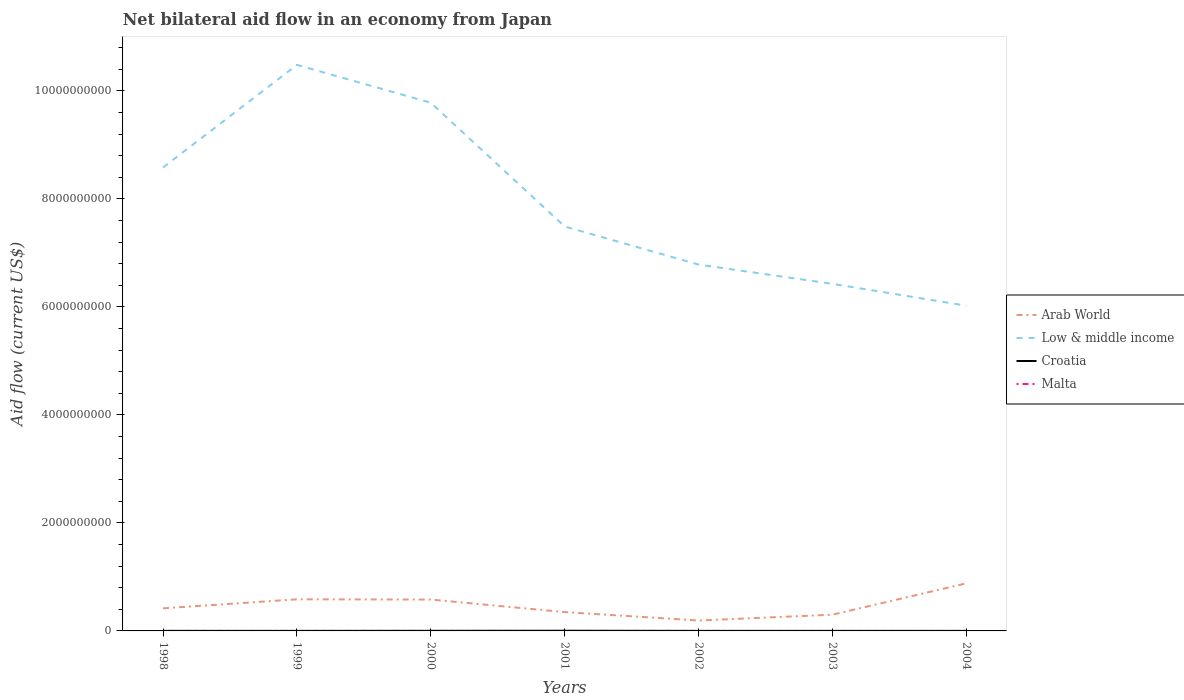Is the number of lines equal to the number of legend labels?
Your response must be concise. Yes. What is the total net bilateral aid flow in Malta in the graph?
Your answer should be very brief. 2.00e+05. What is the difference between the highest and the second highest net bilateral aid flow in Malta?
Offer a terse response. 3.60e+05. What is the difference between the highest and the lowest net bilateral aid flow in Arab World?
Your answer should be compact. 3. Is the net bilateral aid flow in Croatia strictly greater than the net bilateral aid flow in Malta over the years?
Provide a succinct answer. No. How many lines are there?
Keep it short and to the point. 4. How many years are there in the graph?
Your answer should be compact. 7. What is the difference between two consecutive major ticks on the Y-axis?
Offer a terse response. 2.00e+09. Does the graph contain any zero values?
Your answer should be very brief. No. What is the title of the graph?
Give a very brief answer. Net bilateral aid flow in an economy from Japan. Does "Turkmenistan" appear as one of the legend labels in the graph?
Your answer should be very brief. No. What is the label or title of the X-axis?
Offer a very short reply. Years. What is the label or title of the Y-axis?
Your response must be concise. Aid flow (current US$). What is the Aid flow (current US$) in Arab World in 1998?
Offer a very short reply. 4.18e+08. What is the Aid flow (current US$) in Low & middle income in 1998?
Offer a terse response. 8.58e+09. What is the Aid flow (current US$) of Croatia in 1998?
Your answer should be compact. 8.20e+05. What is the Aid flow (current US$) of Arab World in 1999?
Ensure brevity in your answer.  5.85e+08. What is the Aid flow (current US$) in Low & middle income in 1999?
Your response must be concise. 1.05e+1. What is the Aid flow (current US$) of Malta in 1999?
Provide a short and direct response. 4.20e+05. What is the Aid flow (current US$) in Arab World in 2000?
Offer a very short reply. 5.81e+08. What is the Aid flow (current US$) in Low & middle income in 2000?
Provide a succinct answer. 9.78e+09. What is the Aid flow (current US$) of Croatia in 2000?
Offer a terse response. 1.73e+06. What is the Aid flow (current US$) in Malta in 2000?
Your answer should be compact. 4.20e+05. What is the Aid flow (current US$) in Arab World in 2001?
Ensure brevity in your answer.  3.49e+08. What is the Aid flow (current US$) of Low & middle income in 2001?
Give a very brief answer. 7.49e+09. What is the Aid flow (current US$) in Croatia in 2001?
Offer a terse response. 3.24e+06. What is the Aid flow (current US$) in Arab World in 2002?
Offer a terse response. 1.93e+08. What is the Aid flow (current US$) of Low & middle income in 2002?
Keep it short and to the point. 6.78e+09. What is the Aid flow (current US$) in Croatia in 2002?
Make the answer very short. 5.10e+05. What is the Aid flow (current US$) in Arab World in 2003?
Your response must be concise. 3.01e+08. What is the Aid flow (current US$) in Low & middle income in 2003?
Ensure brevity in your answer.  6.43e+09. What is the Aid flow (current US$) of Malta in 2003?
Ensure brevity in your answer.  7.00e+04. What is the Aid flow (current US$) of Arab World in 2004?
Your answer should be very brief. 8.81e+08. What is the Aid flow (current US$) of Low & middle income in 2004?
Keep it short and to the point. 6.02e+09. What is the Aid flow (current US$) of Croatia in 2004?
Make the answer very short. 6.90e+05. Across all years, what is the maximum Aid flow (current US$) of Arab World?
Give a very brief answer. 8.81e+08. Across all years, what is the maximum Aid flow (current US$) in Low & middle income?
Provide a succinct answer. 1.05e+1. Across all years, what is the maximum Aid flow (current US$) of Croatia?
Your answer should be compact. 3.24e+06. Across all years, what is the maximum Aid flow (current US$) in Malta?
Give a very brief answer. 4.20e+05. Across all years, what is the minimum Aid flow (current US$) in Arab World?
Make the answer very short. 1.93e+08. Across all years, what is the minimum Aid flow (current US$) in Low & middle income?
Ensure brevity in your answer.  6.02e+09. Across all years, what is the minimum Aid flow (current US$) in Croatia?
Make the answer very short. 4.90e+05. Across all years, what is the minimum Aid flow (current US$) in Malta?
Give a very brief answer. 6.00e+04. What is the total Aid flow (current US$) of Arab World in the graph?
Your response must be concise. 3.31e+09. What is the total Aid flow (current US$) in Low & middle income in the graph?
Ensure brevity in your answer.  5.56e+1. What is the total Aid flow (current US$) of Croatia in the graph?
Offer a terse response. 8.48e+06. What is the total Aid flow (current US$) of Malta in the graph?
Ensure brevity in your answer.  1.65e+06. What is the difference between the Aid flow (current US$) of Arab World in 1998 and that in 1999?
Ensure brevity in your answer.  -1.67e+08. What is the difference between the Aid flow (current US$) of Low & middle income in 1998 and that in 1999?
Offer a very short reply. -1.90e+09. What is the difference between the Aid flow (current US$) of Croatia in 1998 and that in 1999?
Provide a succinct answer. 3.30e+05. What is the difference between the Aid flow (current US$) in Arab World in 1998 and that in 2000?
Ensure brevity in your answer.  -1.63e+08. What is the difference between the Aid flow (current US$) in Low & middle income in 1998 and that in 2000?
Give a very brief answer. -1.20e+09. What is the difference between the Aid flow (current US$) of Croatia in 1998 and that in 2000?
Ensure brevity in your answer.  -9.10e+05. What is the difference between the Aid flow (current US$) of Malta in 1998 and that in 2000?
Your answer should be compact. -1.40e+05. What is the difference between the Aid flow (current US$) in Arab World in 1998 and that in 2001?
Provide a short and direct response. 6.95e+07. What is the difference between the Aid flow (current US$) of Low & middle income in 1998 and that in 2001?
Your response must be concise. 1.09e+09. What is the difference between the Aid flow (current US$) of Croatia in 1998 and that in 2001?
Provide a short and direct response. -2.42e+06. What is the difference between the Aid flow (current US$) of Arab World in 1998 and that in 2002?
Your answer should be compact. 2.26e+08. What is the difference between the Aid flow (current US$) in Low & middle income in 1998 and that in 2002?
Your answer should be very brief. 1.80e+09. What is the difference between the Aid flow (current US$) in Croatia in 1998 and that in 2002?
Give a very brief answer. 3.10e+05. What is the difference between the Aid flow (current US$) of Arab World in 1998 and that in 2003?
Offer a very short reply. 1.18e+08. What is the difference between the Aid flow (current US$) of Low & middle income in 1998 and that in 2003?
Offer a very short reply. 2.15e+09. What is the difference between the Aid flow (current US$) in Croatia in 1998 and that in 2003?
Ensure brevity in your answer.  -1.80e+05. What is the difference between the Aid flow (current US$) in Malta in 1998 and that in 2003?
Offer a terse response. 2.10e+05. What is the difference between the Aid flow (current US$) in Arab World in 1998 and that in 2004?
Offer a terse response. -4.63e+08. What is the difference between the Aid flow (current US$) of Low & middle income in 1998 and that in 2004?
Give a very brief answer. 2.56e+09. What is the difference between the Aid flow (current US$) of Croatia in 1998 and that in 2004?
Provide a short and direct response. 1.30e+05. What is the difference between the Aid flow (current US$) in Malta in 1998 and that in 2004?
Offer a terse response. 2.20e+05. What is the difference between the Aid flow (current US$) in Arab World in 1999 and that in 2000?
Ensure brevity in your answer.  4.22e+06. What is the difference between the Aid flow (current US$) of Low & middle income in 1999 and that in 2000?
Ensure brevity in your answer.  7.01e+08. What is the difference between the Aid flow (current US$) of Croatia in 1999 and that in 2000?
Your answer should be compact. -1.24e+06. What is the difference between the Aid flow (current US$) in Arab World in 1999 and that in 2001?
Give a very brief answer. 2.36e+08. What is the difference between the Aid flow (current US$) in Low & middle income in 1999 and that in 2001?
Keep it short and to the point. 2.99e+09. What is the difference between the Aid flow (current US$) of Croatia in 1999 and that in 2001?
Ensure brevity in your answer.  -2.75e+06. What is the difference between the Aid flow (current US$) of Arab World in 1999 and that in 2002?
Give a very brief answer. 3.93e+08. What is the difference between the Aid flow (current US$) in Low & middle income in 1999 and that in 2002?
Give a very brief answer. 3.70e+09. What is the difference between the Aid flow (current US$) in Croatia in 1999 and that in 2002?
Provide a succinct answer. -2.00e+04. What is the difference between the Aid flow (current US$) in Arab World in 1999 and that in 2003?
Ensure brevity in your answer.  2.84e+08. What is the difference between the Aid flow (current US$) of Low & middle income in 1999 and that in 2003?
Your answer should be compact. 4.05e+09. What is the difference between the Aid flow (current US$) of Croatia in 1999 and that in 2003?
Give a very brief answer. -5.10e+05. What is the difference between the Aid flow (current US$) in Arab World in 1999 and that in 2004?
Give a very brief answer. -2.96e+08. What is the difference between the Aid flow (current US$) in Low & middle income in 1999 and that in 2004?
Offer a terse response. 4.46e+09. What is the difference between the Aid flow (current US$) in Arab World in 2000 and that in 2001?
Offer a very short reply. 2.32e+08. What is the difference between the Aid flow (current US$) of Low & middle income in 2000 and that in 2001?
Make the answer very short. 2.29e+09. What is the difference between the Aid flow (current US$) of Croatia in 2000 and that in 2001?
Your response must be concise. -1.51e+06. What is the difference between the Aid flow (current US$) of Arab World in 2000 and that in 2002?
Offer a terse response. 3.88e+08. What is the difference between the Aid flow (current US$) of Low & middle income in 2000 and that in 2002?
Offer a very short reply. 3.00e+09. What is the difference between the Aid flow (current US$) in Croatia in 2000 and that in 2002?
Ensure brevity in your answer.  1.22e+06. What is the difference between the Aid flow (current US$) of Malta in 2000 and that in 2002?
Provide a succinct answer. 2.40e+05. What is the difference between the Aid flow (current US$) of Arab World in 2000 and that in 2003?
Offer a very short reply. 2.80e+08. What is the difference between the Aid flow (current US$) of Low & middle income in 2000 and that in 2003?
Your answer should be compact. 3.35e+09. What is the difference between the Aid flow (current US$) of Croatia in 2000 and that in 2003?
Ensure brevity in your answer.  7.30e+05. What is the difference between the Aid flow (current US$) of Malta in 2000 and that in 2003?
Give a very brief answer. 3.50e+05. What is the difference between the Aid flow (current US$) of Arab World in 2000 and that in 2004?
Give a very brief answer. -3.00e+08. What is the difference between the Aid flow (current US$) of Low & middle income in 2000 and that in 2004?
Provide a short and direct response. 3.76e+09. What is the difference between the Aid flow (current US$) of Croatia in 2000 and that in 2004?
Your answer should be compact. 1.04e+06. What is the difference between the Aid flow (current US$) of Malta in 2000 and that in 2004?
Provide a succinct answer. 3.60e+05. What is the difference between the Aid flow (current US$) of Arab World in 2001 and that in 2002?
Your response must be concise. 1.56e+08. What is the difference between the Aid flow (current US$) of Low & middle income in 2001 and that in 2002?
Your answer should be compact. 7.06e+08. What is the difference between the Aid flow (current US$) in Croatia in 2001 and that in 2002?
Make the answer very short. 2.73e+06. What is the difference between the Aid flow (current US$) in Malta in 2001 and that in 2002?
Ensure brevity in your answer.  4.00e+04. What is the difference between the Aid flow (current US$) of Arab World in 2001 and that in 2003?
Keep it short and to the point. 4.80e+07. What is the difference between the Aid flow (current US$) in Low & middle income in 2001 and that in 2003?
Offer a terse response. 1.06e+09. What is the difference between the Aid flow (current US$) in Croatia in 2001 and that in 2003?
Offer a terse response. 2.24e+06. What is the difference between the Aid flow (current US$) of Arab World in 2001 and that in 2004?
Offer a terse response. -5.33e+08. What is the difference between the Aid flow (current US$) in Low & middle income in 2001 and that in 2004?
Your response must be concise. 1.47e+09. What is the difference between the Aid flow (current US$) in Croatia in 2001 and that in 2004?
Offer a terse response. 2.55e+06. What is the difference between the Aid flow (current US$) in Arab World in 2002 and that in 2003?
Provide a short and direct response. -1.08e+08. What is the difference between the Aid flow (current US$) in Low & middle income in 2002 and that in 2003?
Your answer should be compact. 3.57e+08. What is the difference between the Aid flow (current US$) in Croatia in 2002 and that in 2003?
Your answer should be very brief. -4.90e+05. What is the difference between the Aid flow (current US$) of Malta in 2002 and that in 2003?
Keep it short and to the point. 1.10e+05. What is the difference between the Aid flow (current US$) of Arab World in 2002 and that in 2004?
Ensure brevity in your answer.  -6.89e+08. What is the difference between the Aid flow (current US$) of Low & middle income in 2002 and that in 2004?
Provide a succinct answer. 7.62e+08. What is the difference between the Aid flow (current US$) in Croatia in 2002 and that in 2004?
Give a very brief answer. -1.80e+05. What is the difference between the Aid flow (current US$) of Malta in 2002 and that in 2004?
Keep it short and to the point. 1.20e+05. What is the difference between the Aid flow (current US$) in Arab World in 2003 and that in 2004?
Keep it short and to the point. -5.81e+08. What is the difference between the Aid flow (current US$) in Low & middle income in 2003 and that in 2004?
Provide a short and direct response. 4.05e+08. What is the difference between the Aid flow (current US$) in Croatia in 2003 and that in 2004?
Offer a very short reply. 3.10e+05. What is the difference between the Aid flow (current US$) in Arab World in 1998 and the Aid flow (current US$) in Low & middle income in 1999?
Ensure brevity in your answer.  -1.01e+1. What is the difference between the Aid flow (current US$) of Arab World in 1998 and the Aid flow (current US$) of Croatia in 1999?
Offer a very short reply. 4.18e+08. What is the difference between the Aid flow (current US$) of Arab World in 1998 and the Aid flow (current US$) of Malta in 1999?
Your answer should be compact. 4.18e+08. What is the difference between the Aid flow (current US$) in Low & middle income in 1998 and the Aid flow (current US$) in Croatia in 1999?
Offer a terse response. 8.58e+09. What is the difference between the Aid flow (current US$) in Low & middle income in 1998 and the Aid flow (current US$) in Malta in 1999?
Provide a short and direct response. 8.58e+09. What is the difference between the Aid flow (current US$) in Arab World in 1998 and the Aid flow (current US$) in Low & middle income in 2000?
Offer a terse response. -9.36e+09. What is the difference between the Aid flow (current US$) of Arab World in 1998 and the Aid flow (current US$) of Croatia in 2000?
Give a very brief answer. 4.17e+08. What is the difference between the Aid flow (current US$) in Arab World in 1998 and the Aid flow (current US$) in Malta in 2000?
Ensure brevity in your answer.  4.18e+08. What is the difference between the Aid flow (current US$) of Low & middle income in 1998 and the Aid flow (current US$) of Croatia in 2000?
Offer a very short reply. 8.58e+09. What is the difference between the Aid flow (current US$) in Low & middle income in 1998 and the Aid flow (current US$) in Malta in 2000?
Keep it short and to the point. 8.58e+09. What is the difference between the Aid flow (current US$) of Croatia in 1998 and the Aid flow (current US$) of Malta in 2000?
Give a very brief answer. 4.00e+05. What is the difference between the Aid flow (current US$) of Arab World in 1998 and the Aid flow (current US$) of Low & middle income in 2001?
Your response must be concise. -7.07e+09. What is the difference between the Aid flow (current US$) of Arab World in 1998 and the Aid flow (current US$) of Croatia in 2001?
Offer a terse response. 4.15e+08. What is the difference between the Aid flow (current US$) in Arab World in 1998 and the Aid flow (current US$) in Malta in 2001?
Give a very brief answer. 4.18e+08. What is the difference between the Aid flow (current US$) in Low & middle income in 1998 and the Aid flow (current US$) in Croatia in 2001?
Offer a very short reply. 8.58e+09. What is the difference between the Aid flow (current US$) of Low & middle income in 1998 and the Aid flow (current US$) of Malta in 2001?
Provide a short and direct response. 8.58e+09. What is the difference between the Aid flow (current US$) in Arab World in 1998 and the Aid flow (current US$) in Low & middle income in 2002?
Provide a short and direct response. -6.37e+09. What is the difference between the Aid flow (current US$) of Arab World in 1998 and the Aid flow (current US$) of Croatia in 2002?
Your response must be concise. 4.18e+08. What is the difference between the Aid flow (current US$) of Arab World in 1998 and the Aid flow (current US$) of Malta in 2002?
Make the answer very short. 4.18e+08. What is the difference between the Aid flow (current US$) of Low & middle income in 1998 and the Aid flow (current US$) of Croatia in 2002?
Give a very brief answer. 8.58e+09. What is the difference between the Aid flow (current US$) of Low & middle income in 1998 and the Aid flow (current US$) of Malta in 2002?
Your answer should be compact. 8.58e+09. What is the difference between the Aid flow (current US$) in Croatia in 1998 and the Aid flow (current US$) in Malta in 2002?
Your response must be concise. 6.40e+05. What is the difference between the Aid flow (current US$) of Arab World in 1998 and the Aid flow (current US$) of Low & middle income in 2003?
Your answer should be compact. -6.01e+09. What is the difference between the Aid flow (current US$) of Arab World in 1998 and the Aid flow (current US$) of Croatia in 2003?
Your answer should be very brief. 4.17e+08. What is the difference between the Aid flow (current US$) in Arab World in 1998 and the Aid flow (current US$) in Malta in 2003?
Keep it short and to the point. 4.18e+08. What is the difference between the Aid flow (current US$) in Low & middle income in 1998 and the Aid flow (current US$) in Croatia in 2003?
Your answer should be very brief. 8.58e+09. What is the difference between the Aid flow (current US$) of Low & middle income in 1998 and the Aid flow (current US$) of Malta in 2003?
Offer a terse response. 8.58e+09. What is the difference between the Aid flow (current US$) of Croatia in 1998 and the Aid flow (current US$) of Malta in 2003?
Your answer should be compact. 7.50e+05. What is the difference between the Aid flow (current US$) of Arab World in 1998 and the Aid flow (current US$) of Low & middle income in 2004?
Offer a terse response. -5.60e+09. What is the difference between the Aid flow (current US$) in Arab World in 1998 and the Aid flow (current US$) in Croatia in 2004?
Provide a succinct answer. 4.18e+08. What is the difference between the Aid flow (current US$) of Arab World in 1998 and the Aid flow (current US$) of Malta in 2004?
Provide a succinct answer. 4.18e+08. What is the difference between the Aid flow (current US$) of Low & middle income in 1998 and the Aid flow (current US$) of Croatia in 2004?
Ensure brevity in your answer.  8.58e+09. What is the difference between the Aid flow (current US$) in Low & middle income in 1998 and the Aid flow (current US$) in Malta in 2004?
Your response must be concise. 8.58e+09. What is the difference between the Aid flow (current US$) in Croatia in 1998 and the Aid flow (current US$) in Malta in 2004?
Give a very brief answer. 7.60e+05. What is the difference between the Aid flow (current US$) in Arab World in 1999 and the Aid flow (current US$) in Low & middle income in 2000?
Offer a terse response. -9.20e+09. What is the difference between the Aid flow (current US$) of Arab World in 1999 and the Aid flow (current US$) of Croatia in 2000?
Offer a very short reply. 5.83e+08. What is the difference between the Aid flow (current US$) in Arab World in 1999 and the Aid flow (current US$) in Malta in 2000?
Make the answer very short. 5.85e+08. What is the difference between the Aid flow (current US$) in Low & middle income in 1999 and the Aid flow (current US$) in Croatia in 2000?
Offer a very short reply. 1.05e+1. What is the difference between the Aid flow (current US$) of Low & middle income in 1999 and the Aid flow (current US$) of Malta in 2000?
Your response must be concise. 1.05e+1. What is the difference between the Aid flow (current US$) in Croatia in 1999 and the Aid flow (current US$) in Malta in 2000?
Offer a very short reply. 7.00e+04. What is the difference between the Aid flow (current US$) of Arab World in 1999 and the Aid flow (current US$) of Low & middle income in 2001?
Your response must be concise. -6.90e+09. What is the difference between the Aid flow (current US$) in Arab World in 1999 and the Aid flow (current US$) in Croatia in 2001?
Offer a terse response. 5.82e+08. What is the difference between the Aid flow (current US$) in Arab World in 1999 and the Aid flow (current US$) in Malta in 2001?
Offer a very short reply. 5.85e+08. What is the difference between the Aid flow (current US$) of Low & middle income in 1999 and the Aid flow (current US$) of Croatia in 2001?
Ensure brevity in your answer.  1.05e+1. What is the difference between the Aid flow (current US$) of Low & middle income in 1999 and the Aid flow (current US$) of Malta in 2001?
Keep it short and to the point. 1.05e+1. What is the difference between the Aid flow (current US$) of Croatia in 1999 and the Aid flow (current US$) of Malta in 2001?
Your response must be concise. 2.70e+05. What is the difference between the Aid flow (current US$) of Arab World in 1999 and the Aid flow (current US$) of Low & middle income in 2002?
Your answer should be very brief. -6.20e+09. What is the difference between the Aid flow (current US$) in Arab World in 1999 and the Aid flow (current US$) in Croatia in 2002?
Ensure brevity in your answer.  5.85e+08. What is the difference between the Aid flow (current US$) of Arab World in 1999 and the Aid flow (current US$) of Malta in 2002?
Provide a short and direct response. 5.85e+08. What is the difference between the Aid flow (current US$) in Low & middle income in 1999 and the Aid flow (current US$) in Croatia in 2002?
Make the answer very short. 1.05e+1. What is the difference between the Aid flow (current US$) in Low & middle income in 1999 and the Aid flow (current US$) in Malta in 2002?
Give a very brief answer. 1.05e+1. What is the difference between the Aid flow (current US$) in Croatia in 1999 and the Aid flow (current US$) in Malta in 2002?
Provide a succinct answer. 3.10e+05. What is the difference between the Aid flow (current US$) of Arab World in 1999 and the Aid flow (current US$) of Low & middle income in 2003?
Keep it short and to the point. -5.84e+09. What is the difference between the Aid flow (current US$) in Arab World in 1999 and the Aid flow (current US$) in Croatia in 2003?
Make the answer very short. 5.84e+08. What is the difference between the Aid flow (current US$) in Arab World in 1999 and the Aid flow (current US$) in Malta in 2003?
Make the answer very short. 5.85e+08. What is the difference between the Aid flow (current US$) of Low & middle income in 1999 and the Aid flow (current US$) of Croatia in 2003?
Provide a succinct answer. 1.05e+1. What is the difference between the Aid flow (current US$) of Low & middle income in 1999 and the Aid flow (current US$) of Malta in 2003?
Your response must be concise. 1.05e+1. What is the difference between the Aid flow (current US$) of Arab World in 1999 and the Aid flow (current US$) of Low & middle income in 2004?
Your answer should be very brief. -5.44e+09. What is the difference between the Aid flow (current US$) of Arab World in 1999 and the Aid flow (current US$) of Croatia in 2004?
Offer a terse response. 5.85e+08. What is the difference between the Aid flow (current US$) in Arab World in 1999 and the Aid flow (current US$) in Malta in 2004?
Give a very brief answer. 5.85e+08. What is the difference between the Aid flow (current US$) of Low & middle income in 1999 and the Aid flow (current US$) of Croatia in 2004?
Provide a succinct answer. 1.05e+1. What is the difference between the Aid flow (current US$) of Low & middle income in 1999 and the Aid flow (current US$) of Malta in 2004?
Your response must be concise. 1.05e+1. What is the difference between the Aid flow (current US$) in Arab World in 2000 and the Aid flow (current US$) in Low & middle income in 2001?
Make the answer very short. -6.91e+09. What is the difference between the Aid flow (current US$) of Arab World in 2000 and the Aid flow (current US$) of Croatia in 2001?
Offer a terse response. 5.78e+08. What is the difference between the Aid flow (current US$) of Arab World in 2000 and the Aid flow (current US$) of Malta in 2001?
Provide a short and direct response. 5.81e+08. What is the difference between the Aid flow (current US$) of Low & middle income in 2000 and the Aid flow (current US$) of Croatia in 2001?
Offer a terse response. 9.78e+09. What is the difference between the Aid flow (current US$) in Low & middle income in 2000 and the Aid flow (current US$) in Malta in 2001?
Provide a short and direct response. 9.78e+09. What is the difference between the Aid flow (current US$) of Croatia in 2000 and the Aid flow (current US$) of Malta in 2001?
Ensure brevity in your answer.  1.51e+06. What is the difference between the Aid flow (current US$) of Arab World in 2000 and the Aid flow (current US$) of Low & middle income in 2002?
Provide a short and direct response. -6.20e+09. What is the difference between the Aid flow (current US$) of Arab World in 2000 and the Aid flow (current US$) of Croatia in 2002?
Provide a succinct answer. 5.80e+08. What is the difference between the Aid flow (current US$) of Arab World in 2000 and the Aid flow (current US$) of Malta in 2002?
Make the answer very short. 5.81e+08. What is the difference between the Aid flow (current US$) of Low & middle income in 2000 and the Aid flow (current US$) of Croatia in 2002?
Your answer should be very brief. 9.78e+09. What is the difference between the Aid flow (current US$) in Low & middle income in 2000 and the Aid flow (current US$) in Malta in 2002?
Provide a short and direct response. 9.78e+09. What is the difference between the Aid flow (current US$) in Croatia in 2000 and the Aid flow (current US$) in Malta in 2002?
Provide a succinct answer. 1.55e+06. What is the difference between the Aid flow (current US$) of Arab World in 2000 and the Aid flow (current US$) of Low & middle income in 2003?
Your answer should be compact. -5.85e+09. What is the difference between the Aid flow (current US$) in Arab World in 2000 and the Aid flow (current US$) in Croatia in 2003?
Keep it short and to the point. 5.80e+08. What is the difference between the Aid flow (current US$) of Arab World in 2000 and the Aid flow (current US$) of Malta in 2003?
Your answer should be very brief. 5.81e+08. What is the difference between the Aid flow (current US$) in Low & middle income in 2000 and the Aid flow (current US$) in Croatia in 2003?
Give a very brief answer. 9.78e+09. What is the difference between the Aid flow (current US$) of Low & middle income in 2000 and the Aid flow (current US$) of Malta in 2003?
Ensure brevity in your answer.  9.78e+09. What is the difference between the Aid flow (current US$) of Croatia in 2000 and the Aid flow (current US$) of Malta in 2003?
Ensure brevity in your answer.  1.66e+06. What is the difference between the Aid flow (current US$) of Arab World in 2000 and the Aid flow (current US$) of Low & middle income in 2004?
Provide a succinct answer. -5.44e+09. What is the difference between the Aid flow (current US$) of Arab World in 2000 and the Aid flow (current US$) of Croatia in 2004?
Make the answer very short. 5.80e+08. What is the difference between the Aid flow (current US$) of Arab World in 2000 and the Aid flow (current US$) of Malta in 2004?
Ensure brevity in your answer.  5.81e+08. What is the difference between the Aid flow (current US$) in Low & middle income in 2000 and the Aid flow (current US$) in Croatia in 2004?
Your answer should be compact. 9.78e+09. What is the difference between the Aid flow (current US$) in Low & middle income in 2000 and the Aid flow (current US$) in Malta in 2004?
Give a very brief answer. 9.78e+09. What is the difference between the Aid flow (current US$) of Croatia in 2000 and the Aid flow (current US$) of Malta in 2004?
Provide a succinct answer. 1.67e+06. What is the difference between the Aid flow (current US$) of Arab World in 2001 and the Aid flow (current US$) of Low & middle income in 2002?
Keep it short and to the point. -6.44e+09. What is the difference between the Aid flow (current US$) of Arab World in 2001 and the Aid flow (current US$) of Croatia in 2002?
Offer a terse response. 3.48e+08. What is the difference between the Aid flow (current US$) of Arab World in 2001 and the Aid flow (current US$) of Malta in 2002?
Your answer should be very brief. 3.49e+08. What is the difference between the Aid flow (current US$) in Low & middle income in 2001 and the Aid flow (current US$) in Croatia in 2002?
Give a very brief answer. 7.49e+09. What is the difference between the Aid flow (current US$) in Low & middle income in 2001 and the Aid flow (current US$) in Malta in 2002?
Give a very brief answer. 7.49e+09. What is the difference between the Aid flow (current US$) of Croatia in 2001 and the Aid flow (current US$) of Malta in 2002?
Your answer should be very brief. 3.06e+06. What is the difference between the Aid flow (current US$) in Arab World in 2001 and the Aid flow (current US$) in Low & middle income in 2003?
Provide a succinct answer. -6.08e+09. What is the difference between the Aid flow (current US$) of Arab World in 2001 and the Aid flow (current US$) of Croatia in 2003?
Provide a short and direct response. 3.48e+08. What is the difference between the Aid flow (current US$) of Arab World in 2001 and the Aid flow (current US$) of Malta in 2003?
Make the answer very short. 3.49e+08. What is the difference between the Aid flow (current US$) in Low & middle income in 2001 and the Aid flow (current US$) in Croatia in 2003?
Your answer should be compact. 7.49e+09. What is the difference between the Aid flow (current US$) in Low & middle income in 2001 and the Aid flow (current US$) in Malta in 2003?
Your answer should be compact. 7.49e+09. What is the difference between the Aid flow (current US$) in Croatia in 2001 and the Aid flow (current US$) in Malta in 2003?
Your answer should be very brief. 3.17e+06. What is the difference between the Aid flow (current US$) of Arab World in 2001 and the Aid flow (current US$) of Low & middle income in 2004?
Your answer should be compact. -5.67e+09. What is the difference between the Aid flow (current US$) in Arab World in 2001 and the Aid flow (current US$) in Croatia in 2004?
Your response must be concise. 3.48e+08. What is the difference between the Aid flow (current US$) in Arab World in 2001 and the Aid flow (current US$) in Malta in 2004?
Offer a very short reply. 3.49e+08. What is the difference between the Aid flow (current US$) in Low & middle income in 2001 and the Aid flow (current US$) in Croatia in 2004?
Offer a very short reply. 7.49e+09. What is the difference between the Aid flow (current US$) in Low & middle income in 2001 and the Aid flow (current US$) in Malta in 2004?
Your answer should be compact. 7.49e+09. What is the difference between the Aid flow (current US$) of Croatia in 2001 and the Aid flow (current US$) of Malta in 2004?
Your response must be concise. 3.18e+06. What is the difference between the Aid flow (current US$) of Arab World in 2002 and the Aid flow (current US$) of Low & middle income in 2003?
Your response must be concise. -6.23e+09. What is the difference between the Aid flow (current US$) in Arab World in 2002 and the Aid flow (current US$) in Croatia in 2003?
Give a very brief answer. 1.92e+08. What is the difference between the Aid flow (current US$) in Arab World in 2002 and the Aid flow (current US$) in Malta in 2003?
Provide a short and direct response. 1.93e+08. What is the difference between the Aid flow (current US$) in Low & middle income in 2002 and the Aid flow (current US$) in Croatia in 2003?
Provide a succinct answer. 6.78e+09. What is the difference between the Aid flow (current US$) of Low & middle income in 2002 and the Aid flow (current US$) of Malta in 2003?
Provide a succinct answer. 6.78e+09. What is the difference between the Aid flow (current US$) in Croatia in 2002 and the Aid flow (current US$) in Malta in 2003?
Your response must be concise. 4.40e+05. What is the difference between the Aid flow (current US$) of Arab World in 2002 and the Aid flow (current US$) of Low & middle income in 2004?
Provide a succinct answer. -5.83e+09. What is the difference between the Aid flow (current US$) in Arab World in 2002 and the Aid flow (current US$) in Croatia in 2004?
Keep it short and to the point. 1.92e+08. What is the difference between the Aid flow (current US$) of Arab World in 2002 and the Aid flow (current US$) of Malta in 2004?
Make the answer very short. 1.93e+08. What is the difference between the Aid flow (current US$) in Low & middle income in 2002 and the Aid flow (current US$) in Croatia in 2004?
Ensure brevity in your answer.  6.78e+09. What is the difference between the Aid flow (current US$) in Low & middle income in 2002 and the Aid flow (current US$) in Malta in 2004?
Provide a short and direct response. 6.78e+09. What is the difference between the Aid flow (current US$) of Croatia in 2002 and the Aid flow (current US$) of Malta in 2004?
Provide a succinct answer. 4.50e+05. What is the difference between the Aid flow (current US$) in Arab World in 2003 and the Aid flow (current US$) in Low & middle income in 2004?
Keep it short and to the point. -5.72e+09. What is the difference between the Aid flow (current US$) of Arab World in 2003 and the Aid flow (current US$) of Croatia in 2004?
Provide a succinct answer. 3.00e+08. What is the difference between the Aid flow (current US$) in Arab World in 2003 and the Aid flow (current US$) in Malta in 2004?
Give a very brief answer. 3.01e+08. What is the difference between the Aid flow (current US$) of Low & middle income in 2003 and the Aid flow (current US$) of Croatia in 2004?
Make the answer very short. 6.43e+09. What is the difference between the Aid flow (current US$) in Low & middle income in 2003 and the Aid flow (current US$) in Malta in 2004?
Provide a succinct answer. 6.43e+09. What is the difference between the Aid flow (current US$) of Croatia in 2003 and the Aid flow (current US$) of Malta in 2004?
Give a very brief answer. 9.40e+05. What is the average Aid flow (current US$) in Arab World per year?
Provide a succinct answer. 4.73e+08. What is the average Aid flow (current US$) in Low & middle income per year?
Offer a terse response. 7.94e+09. What is the average Aid flow (current US$) of Croatia per year?
Your answer should be compact. 1.21e+06. What is the average Aid flow (current US$) in Malta per year?
Your response must be concise. 2.36e+05. In the year 1998, what is the difference between the Aid flow (current US$) of Arab World and Aid flow (current US$) of Low & middle income?
Provide a succinct answer. -8.16e+09. In the year 1998, what is the difference between the Aid flow (current US$) of Arab World and Aid flow (current US$) of Croatia?
Offer a very short reply. 4.18e+08. In the year 1998, what is the difference between the Aid flow (current US$) in Arab World and Aid flow (current US$) in Malta?
Your answer should be compact. 4.18e+08. In the year 1998, what is the difference between the Aid flow (current US$) in Low & middle income and Aid flow (current US$) in Croatia?
Your answer should be very brief. 8.58e+09. In the year 1998, what is the difference between the Aid flow (current US$) in Low & middle income and Aid flow (current US$) in Malta?
Your answer should be very brief. 8.58e+09. In the year 1998, what is the difference between the Aid flow (current US$) in Croatia and Aid flow (current US$) in Malta?
Your response must be concise. 5.40e+05. In the year 1999, what is the difference between the Aid flow (current US$) of Arab World and Aid flow (current US$) of Low & middle income?
Make the answer very short. -9.90e+09. In the year 1999, what is the difference between the Aid flow (current US$) of Arab World and Aid flow (current US$) of Croatia?
Provide a short and direct response. 5.85e+08. In the year 1999, what is the difference between the Aid flow (current US$) of Arab World and Aid flow (current US$) of Malta?
Give a very brief answer. 5.85e+08. In the year 1999, what is the difference between the Aid flow (current US$) of Low & middle income and Aid flow (current US$) of Croatia?
Give a very brief answer. 1.05e+1. In the year 1999, what is the difference between the Aid flow (current US$) in Low & middle income and Aid flow (current US$) in Malta?
Provide a succinct answer. 1.05e+1. In the year 1999, what is the difference between the Aid flow (current US$) of Croatia and Aid flow (current US$) of Malta?
Provide a succinct answer. 7.00e+04. In the year 2000, what is the difference between the Aid flow (current US$) of Arab World and Aid flow (current US$) of Low & middle income?
Give a very brief answer. -9.20e+09. In the year 2000, what is the difference between the Aid flow (current US$) in Arab World and Aid flow (current US$) in Croatia?
Your answer should be very brief. 5.79e+08. In the year 2000, what is the difference between the Aid flow (current US$) of Arab World and Aid flow (current US$) of Malta?
Provide a short and direct response. 5.81e+08. In the year 2000, what is the difference between the Aid flow (current US$) of Low & middle income and Aid flow (current US$) of Croatia?
Make the answer very short. 9.78e+09. In the year 2000, what is the difference between the Aid flow (current US$) of Low & middle income and Aid flow (current US$) of Malta?
Ensure brevity in your answer.  9.78e+09. In the year 2000, what is the difference between the Aid flow (current US$) in Croatia and Aid flow (current US$) in Malta?
Keep it short and to the point. 1.31e+06. In the year 2001, what is the difference between the Aid flow (current US$) of Arab World and Aid flow (current US$) of Low & middle income?
Your answer should be very brief. -7.14e+09. In the year 2001, what is the difference between the Aid flow (current US$) of Arab World and Aid flow (current US$) of Croatia?
Your response must be concise. 3.46e+08. In the year 2001, what is the difference between the Aid flow (current US$) in Arab World and Aid flow (current US$) in Malta?
Provide a short and direct response. 3.49e+08. In the year 2001, what is the difference between the Aid flow (current US$) in Low & middle income and Aid flow (current US$) in Croatia?
Your answer should be very brief. 7.49e+09. In the year 2001, what is the difference between the Aid flow (current US$) in Low & middle income and Aid flow (current US$) in Malta?
Your answer should be compact. 7.49e+09. In the year 2001, what is the difference between the Aid flow (current US$) in Croatia and Aid flow (current US$) in Malta?
Your answer should be compact. 3.02e+06. In the year 2002, what is the difference between the Aid flow (current US$) of Arab World and Aid flow (current US$) of Low & middle income?
Make the answer very short. -6.59e+09. In the year 2002, what is the difference between the Aid flow (current US$) of Arab World and Aid flow (current US$) of Croatia?
Offer a very short reply. 1.92e+08. In the year 2002, what is the difference between the Aid flow (current US$) in Arab World and Aid flow (current US$) in Malta?
Provide a short and direct response. 1.92e+08. In the year 2002, what is the difference between the Aid flow (current US$) of Low & middle income and Aid flow (current US$) of Croatia?
Make the answer very short. 6.78e+09. In the year 2002, what is the difference between the Aid flow (current US$) of Low & middle income and Aid flow (current US$) of Malta?
Make the answer very short. 6.78e+09. In the year 2002, what is the difference between the Aid flow (current US$) of Croatia and Aid flow (current US$) of Malta?
Your answer should be compact. 3.30e+05. In the year 2003, what is the difference between the Aid flow (current US$) in Arab World and Aid flow (current US$) in Low & middle income?
Your answer should be compact. -6.13e+09. In the year 2003, what is the difference between the Aid flow (current US$) of Arab World and Aid flow (current US$) of Croatia?
Give a very brief answer. 3.00e+08. In the year 2003, what is the difference between the Aid flow (current US$) of Arab World and Aid flow (current US$) of Malta?
Ensure brevity in your answer.  3.01e+08. In the year 2003, what is the difference between the Aid flow (current US$) in Low & middle income and Aid flow (current US$) in Croatia?
Offer a very short reply. 6.43e+09. In the year 2003, what is the difference between the Aid flow (current US$) of Low & middle income and Aid flow (current US$) of Malta?
Make the answer very short. 6.43e+09. In the year 2003, what is the difference between the Aid flow (current US$) of Croatia and Aid flow (current US$) of Malta?
Give a very brief answer. 9.30e+05. In the year 2004, what is the difference between the Aid flow (current US$) of Arab World and Aid flow (current US$) of Low & middle income?
Your answer should be compact. -5.14e+09. In the year 2004, what is the difference between the Aid flow (current US$) in Arab World and Aid flow (current US$) in Croatia?
Offer a very short reply. 8.81e+08. In the year 2004, what is the difference between the Aid flow (current US$) in Arab World and Aid flow (current US$) in Malta?
Offer a terse response. 8.81e+08. In the year 2004, what is the difference between the Aid flow (current US$) of Low & middle income and Aid flow (current US$) of Croatia?
Keep it short and to the point. 6.02e+09. In the year 2004, what is the difference between the Aid flow (current US$) of Low & middle income and Aid flow (current US$) of Malta?
Offer a very short reply. 6.02e+09. In the year 2004, what is the difference between the Aid flow (current US$) of Croatia and Aid flow (current US$) of Malta?
Keep it short and to the point. 6.30e+05. What is the ratio of the Aid flow (current US$) of Arab World in 1998 to that in 1999?
Ensure brevity in your answer.  0.71. What is the ratio of the Aid flow (current US$) of Low & middle income in 1998 to that in 1999?
Your response must be concise. 0.82. What is the ratio of the Aid flow (current US$) of Croatia in 1998 to that in 1999?
Make the answer very short. 1.67. What is the ratio of the Aid flow (current US$) of Arab World in 1998 to that in 2000?
Keep it short and to the point. 0.72. What is the ratio of the Aid flow (current US$) of Low & middle income in 1998 to that in 2000?
Your answer should be compact. 0.88. What is the ratio of the Aid flow (current US$) of Croatia in 1998 to that in 2000?
Your answer should be compact. 0.47. What is the ratio of the Aid flow (current US$) in Malta in 1998 to that in 2000?
Make the answer very short. 0.67. What is the ratio of the Aid flow (current US$) in Arab World in 1998 to that in 2001?
Offer a terse response. 1.2. What is the ratio of the Aid flow (current US$) of Low & middle income in 1998 to that in 2001?
Your answer should be compact. 1.15. What is the ratio of the Aid flow (current US$) in Croatia in 1998 to that in 2001?
Ensure brevity in your answer.  0.25. What is the ratio of the Aid flow (current US$) of Malta in 1998 to that in 2001?
Make the answer very short. 1.27. What is the ratio of the Aid flow (current US$) in Arab World in 1998 to that in 2002?
Give a very brief answer. 2.17. What is the ratio of the Aid flow (current US$) of Low & middle income in 1998 to that in 2002?
Ensure brevity in your answer.  1.26. What is the ratio of the Aid flow (current US$) in Croatia in 1998 to that in 2002?
Provide a short and direct response. 1.61. What is the ratio of the Aid flow (current US$) of Malta in 1998 to that in 2002?
Offer a very short reply. 1.56. What is the ratio of the Aid flow (current US$) in Arab World in 1998 to that in 2003?
Ensure brevity in your answer.  1.39. What is the ratio of the Aid flow (current US$) of Low & middle income in 1998 to that in 2003?
Your answer should be compact. 1.34. What is the ratio of the Aid flow (current US$) in Croatia in 1998 to that in 2003?
Your answer should be compact. 0.82. What is the ratio of the Aid flow (current US$) of Arab World in 1998 to that in 2004?
Make the answer very short. 0.47. What is the ratio of the Aid flow (current US$) of Low & middle income in 1998 to that in 2004?
Give a very brief answer. 1.43. What is the ratio of the Aid flow (current US$) in Croatia in 1998 to that in 2004?
Your answer should be compact. 1.19. What is the ratio of the Aid flow (current US$) in Malta in 1998 to that in 2004?
Keep it short and to the point. 4.67. What is the ratio of the Aid flow (current US$) in Arab World in 1999 to that in 2000?
Give a very brief answer. 1.01. What is the ratio of the Aid flow (current US$) in Low & middle income in 1999 to that in 2000?
Your answer should be compact. 1.07. What is the ratio of the Aid flow (current US$) of Croatia in 1999 to that in 2000?
Your answer should be compact. 0.28. What is the ratio of the Aid flow (current US$) of Arab World in 1999 to that in 2001?
Provide a succinct answer. 1.68. What is the ratio of the Aid flow (current US$) of Low & middle income in 1999 to that in 2001?
Your answer should be compact. 1.4. What is the ratio of the Aid flow (current US$) in Croatia in 1999 to that in 2001?
Offer a terse response. 0.15. What is the ratio of the Aid flow (current US$) in Malta in 1999 to that in 2001?
Provide a succinct answer. 1.91. What is the ratio of the Aid flow (current US$) of Arab World in 1999 to that in 2002?
Ensure brevity in your answer.  3.04. What is the ratio of the Aid flow (current US$) in Low & middle income in 1999 to that in 2002?
Ensure brevity in your answer.  1.55. What is the ratio of the Aid flow (current US$) of Croatia in 1999 to that in 2002?
Keep it short and to the point. 0.96. What is the ratio of the Aid flow (current US$) of Malta in 1999 to that in 2002?
Your answer should be very brief. 2.33. What is the ratio of the Aid flow (current US$) of Arab World in 1999 to that in 2003?
Ensure brevity in your answer.  1.95. What is the ratio of the Aid flow (current US$) in Low & middle income in 1999 to that in 2003?
Offer a very short reply. 1.63. What is the ratio of the Aid flow (current US$) in Croatia in 1999 to that in 2003?
Your answer should be very brief. 0.49. What is the ratio of the Aid flow (current US$) of Arab World in 1999 to that in 2004?
Offer a terse response. 0.66. What is the ratio of the Aid flow (current US$) of Low & middle income in 1999 to that in 2004?
Provide a succinct answer. 1.74. What is the ratio of the Aid flow (current US$) of Croatia in 1999 to that in 2004?
Your response must be concise. 0.71. What is the ratio of the Aid flow (current US$) in Malta in 1999 to that in 2004?
Keep it short and to the point. 7. What is the ratio of the Aid flow (current US$) of Arab World in 2000 to that in 2001?
Offer a very short reply. 1.67. What is the ratio of the Aid flow (current US$) of Low & middle income in 2000 to that in 2001?
Ensure brevity in your answer.  1.31. What is the ratio of the Aid flow (current US$) in Croatia in 2000 to that in 2001?
Provide a succinct answer. 0.53. What is the ratio of the Aid flow (current US$) in Malta in 2000 to that in 2001?
Provide a short and direct response. 1.91. What is the ratio of the Aid flow (current US$) of Arab World in 2000 to that in 2002?
Provide a succinct answer. 3.02. What is the ratio of the Aid flow (current US$) in Low & middle income in 2000 to that in 2002?
Provide a succinct answer. 1.44. What is the ratio of the Aid flow (current US$) of Croatia in 2000 to that in 2002?
Offer a terse response. 3.39. What is the ratio of the Aid flow (current US$) in Malta in 2000 to that in 2002?
Ensure brevity in your answer.  2.33. What is the ratio of the Aid flow (current US$) of Arab World in 2000 to that in 2003?
Offer a terse response. 1.93. What is the ratio of the Aid flow (current US$) in Low & middle income in 2000 to that in 2003?
Your answer should be very brief. 1.52. What is the ratio of the Aid flow (current US$) of Croatia in 2000 to that in 2003?
Give a very brief answer. 1.73. What is the ratio of the Aid flow (current US$) in Malta in 2000 to that in 2003?
Your response must be concise. 6. What is the ratio of the Aid flow (current US$) in Arab World in 2000 to that in 2004?
Your response must be concise. 0.66. What is the ratio of the Aid flow (current US$) of Low & middle income in 2000 to that in 2004?
Your answer should be compact. 1.62. What is the ratio of the Aid flow (current US$) of Croatia in 2000 to that in 2004?
Offer a very short reply. 2.51. What is the ratio of the Aid flow (current US$) of Arab World in 2001 to that in 2002?
Give a very brief answer. 1.81. What is the ratio of the Aid flow (current US$) in Low & middle income in 2001 to that in 2002?
Your answer should be very brief. 1.1. What is the ratio of the Aid flow (current US$) of Croatia in 2001 to that in 2002?
Your answer should be very brief. 6.35. What is the ratio of the Aid flow (current US$) in Malta in 2001 to that in 2002?
Ensure brevity in your answer.  1.22. What is the ratio of the Aid flow (current US$) of Arab World in 2001 to that in 2003?
Your response must be concise. 1.16. What is the ratio of the Aid flow (current US$) of Low & middle income in 2001 to that in 2003?
Keep it short and to the point. 1.17. What is the ratio of the Aid flow (current US$) in Croatia in 2001 to that in 2003?
Keep it short and to the point. 3.24. What is the ratio of the Aid flow (current US$) of Malta in 2001 to that in 2003?
Ensure brevity in your answer.  3.14. What is the ratio of the Aid flow (current US$) of Arab World in 2001 to that in 2004?
Your answer should be very brief. 0.4. What is the ratio of the Aid flow (current US$) of Low & middle income in 2001 to that in 2004?
Make the answer very short. 1.24. What is the ratio of the Aid flow (current US$) in Croatia in 2001 to that in 2004?
Provide a succinct answer. 4.7. What is the ratio of the Aid flow (current US$) in Malta in 2001 to that in 2004?
Your answer should be very brief. 3.67. What is the ratio of the Aid flow (current US$) in Arab World in 2002 to that in 2003?
Offer a terse response. 0.64. What is the ratio of the Aid flow (current US$) of Low & middle income in 2002 to that in 2003?
Give a very brief answer. 1.06. What is the ratio of the Aid flow (current US$) of Croatia in 2002 to that in 2003?
Provide a short and direct response. 0.51. What is the ratio of the Aid flow (current US$) of Malta in 2002 to that in 2003?
Offer a very short reply. 2.57. What is the ratio of the Aid flow (current US$) in Arab World in 2002 to that in 2004?
Provide a short and direct response. 0.22. What is the ratio of the Aid flow (current US$) in Low & middle income in 2002 to that in 2004?
Make the answer very short. 1.13. What is the ratio of the Aid flow (current US$) in Croatia in 2002 to that in 2004?
Make the answer very short. 0.74. What is the ratio of the Aid flow (current US$) in Malta in 2002 to that in 2004?
Make the answer very short. 3. What is the ratio of the Aid flow (current US$) of Arab World in 2003 to that in 2004?
Provide a succinct answer. 0.34. What is the ratio of the Aid flow (current US$) of Low & middle income in 2003 to that in 2004?
Provide a short and direct response. 1.07. What is the ratio of the Aid flow (current US$) of Croatia in 2003 to that in 2004?
Your answer should be very brief. 1.45. What is the ratio of the Aid flow (current US$) of Malta in 2003 to that in 2004?
Keep it short and to the point. 1.17. What is the difference between the highest and the second highest Aid flow (current US$) of Arab World?
Your answer should be very brief. 2.96e+08. What is the difference between the highest and the second highest Aid flow (current US$) of Low & middle income?
Ensure brevity in your answer.  7.01e+08. What is the difference between the highest and the second highest Aid flow (current US$) of Croatia?
Keep it short and to the point. 1.51e+06. What is the difference between the highest and the lowest Aid flow (current US$) in Arab World?
Give a very brief answer. 6.89e+08. What is the difference between the highest and the lowest Aid flow (current US$) in Low & middle income?
Make the answer very short. 4.46e+09. What is the difference between the highest and the lowest Aid flow (current US$) in Croatia?
Provide a short and direct response. 2.75e+06. What is the difference between the highest and the lowest Aid flow (current US$) in Malta?
Offer a terse response. 3.60e+05. 